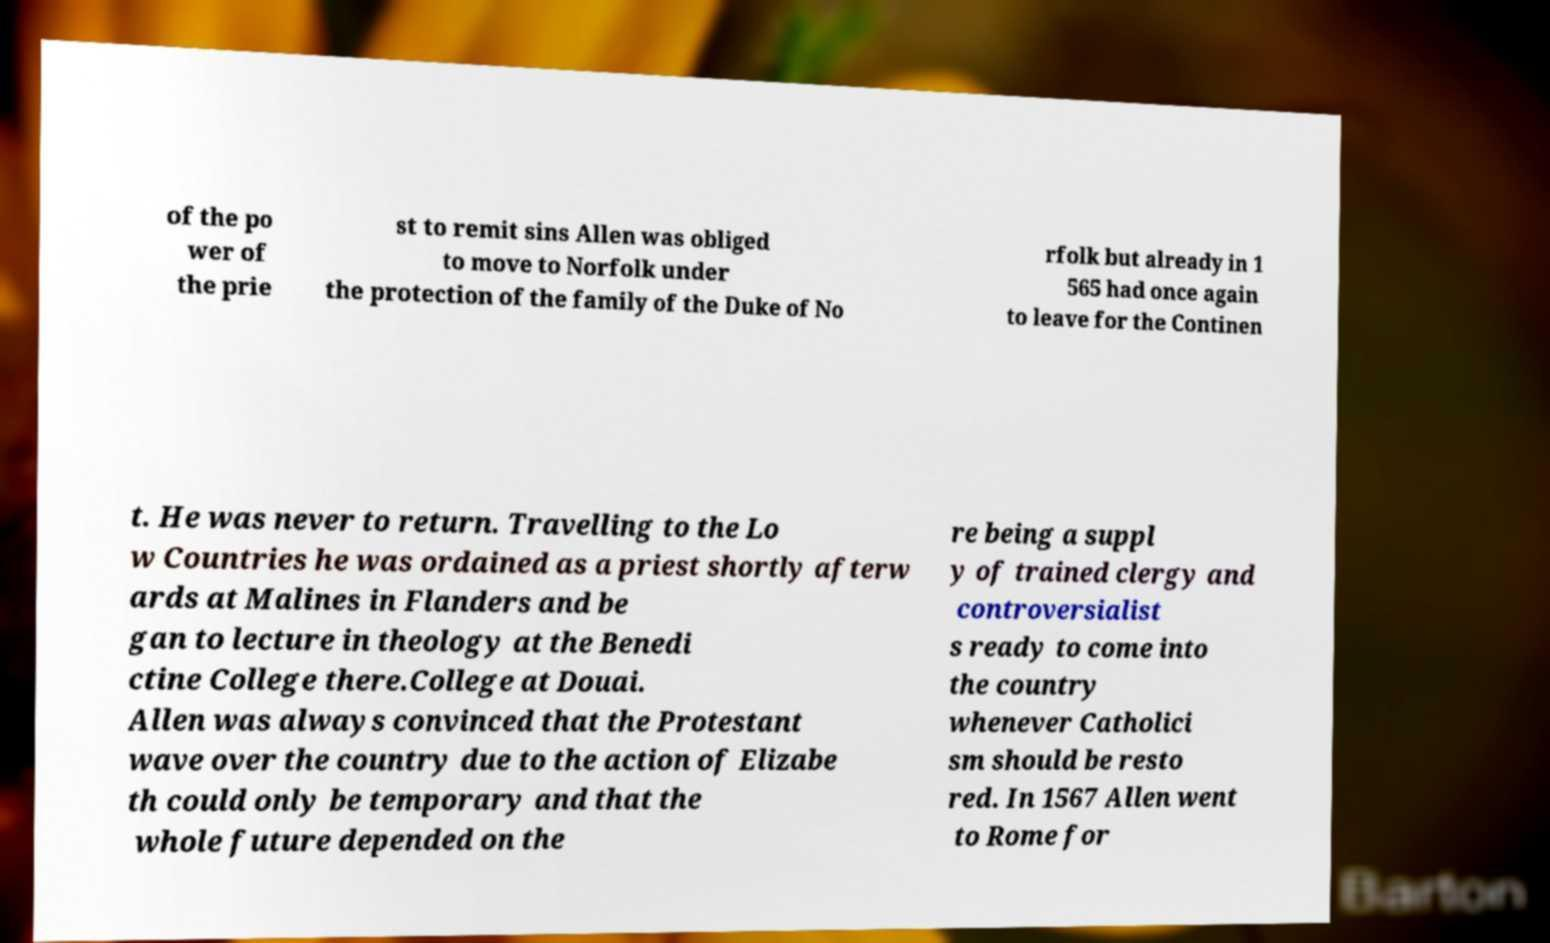There's text embedded in this image that I need extracted. Can you transcribe it verbatim? of the po wer of the prie st to remit sins Allen was obliged to move to Norfolk under the protection of the family of the Duke of No rfolk but already in 1 565 had once again to leave for the Continen t. He was never to return. Travelling to the Lo w Countries he was ordained as a priest shortly afterw ards at Malines in Flanders and be gan to lecture in theology at the Benedi ctine College there.College at Douai. Allen was always convinced that the Protestant wave over the country due to the action of Elizabe th could only be temporary and that the whole future depended on the re being a suppl y of trained clergy and controversialist s ready to come into the country whenever Catholici sm should be resto red. In 1567 Allen went to Rome for 